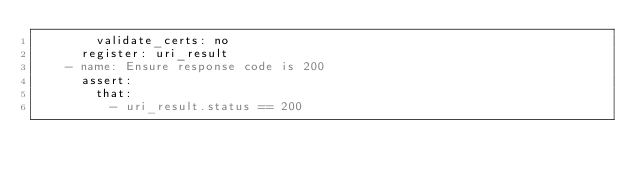Convert code to text. <code><loc_0><loc_0><loc_500><loc_500><_YAML_>        validate_certs: no
      register: uri_result
    - name: Ensure response code is 200
      assert:
        that:
          - uri_result.status == 200
</code> 